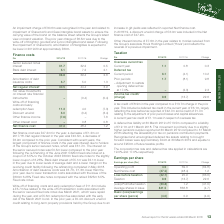According to Premier Foods Plc's financial document, What was the Net finance cost in 2018/19? According to the financial document, £47.2m. The relevant text states: "Net finance cost was £47.2m for the year; a decrease of £1.2m on 2017/18. Net regular interest in the year was £40.5m, a decreas..." Also, What was the Net regular interest in 2018/19? According to the financial document, £40.5m. The relevant text states: "m on 2017/18. Net regular interest in the year was £40.5m, a decrease of £3.9m compared to the prior year. Consistent with recent years, the largest componen..." Also, What was the Net finance cost in 2017/18? According to the financial document, 48.4 (in millions). The relevant text states: "Net finance cost 47.2 48.4 1.2..." Also, can you calculate: What is the average Senior secured notes interest, for the year 2018/19 to 2017/18? To answer this question, I need to perform calculations using the financial data. The calculation is: (31.7+32.2) / 2, which equals 31.95 (in millions). This is based on the information: "2017/18 Change Senior secured notes interest 31.7 32.2 0.5 Bank debt interest 5.1 7.2 2.1 8/19 2017/18 Change Senior secured notes interest 31.7 32.2 0.5 Bank debt interest 5.1 7.2 2.1..." The key data points involved are: 31.7, 32.2. Also, can you calculate: What is the average Bank debt interest, for the year 2018/19 to 2017/18? To answer this question, I need to perform calculations using the financial data. The calculation is: (5.1+7.2) / 2, which equals 6.15 (in millions). This is based on the information: "d notes interest 31.7 32.2 0.5 Bank debt interest 5.1 7.2 2.1 tes interest 31.7 32.2 0.5 Bank debt interest 5.1 7.2 2.1..." The key data points involved are: 5.1, 7.2. Also, can you calculate: What is the average Net regular interest, for the year 2018/19 to 2017/18? To answer this question, I need to perform calculations using the financial data. The calculation is: (40.5+44.4) / 2, which equals 42.45 (in millions). This is based on the information: "Net regular interest 5 40.5 44.4 3.9 Fair value movements on interest rate financial instruments – (0.4) (0.4) Write-off of fin Net regular interest 5 40.5 44.4 3.9 Fair value movements on interest ra..." The key data points involved are: 40.5, 44.4. 